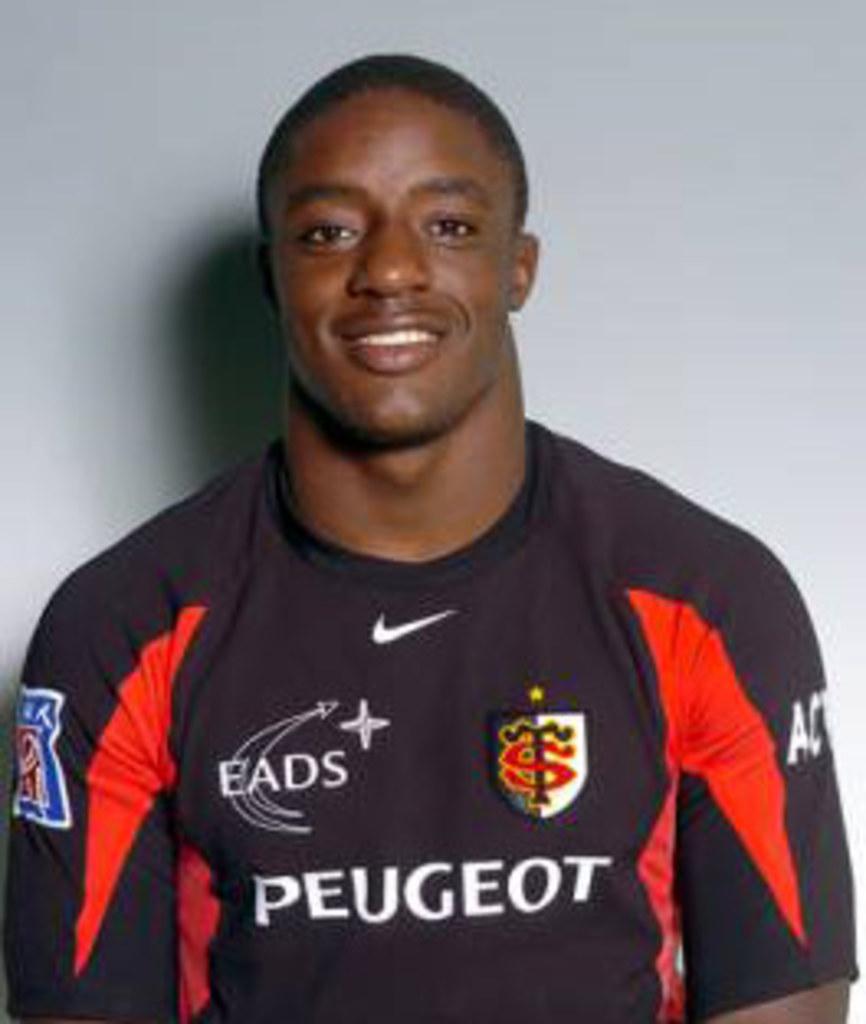What is written across the players chest?
Give a very brief answer. Peugeot. What team does the boy play for?
Make the answer very short. Peugeot. 